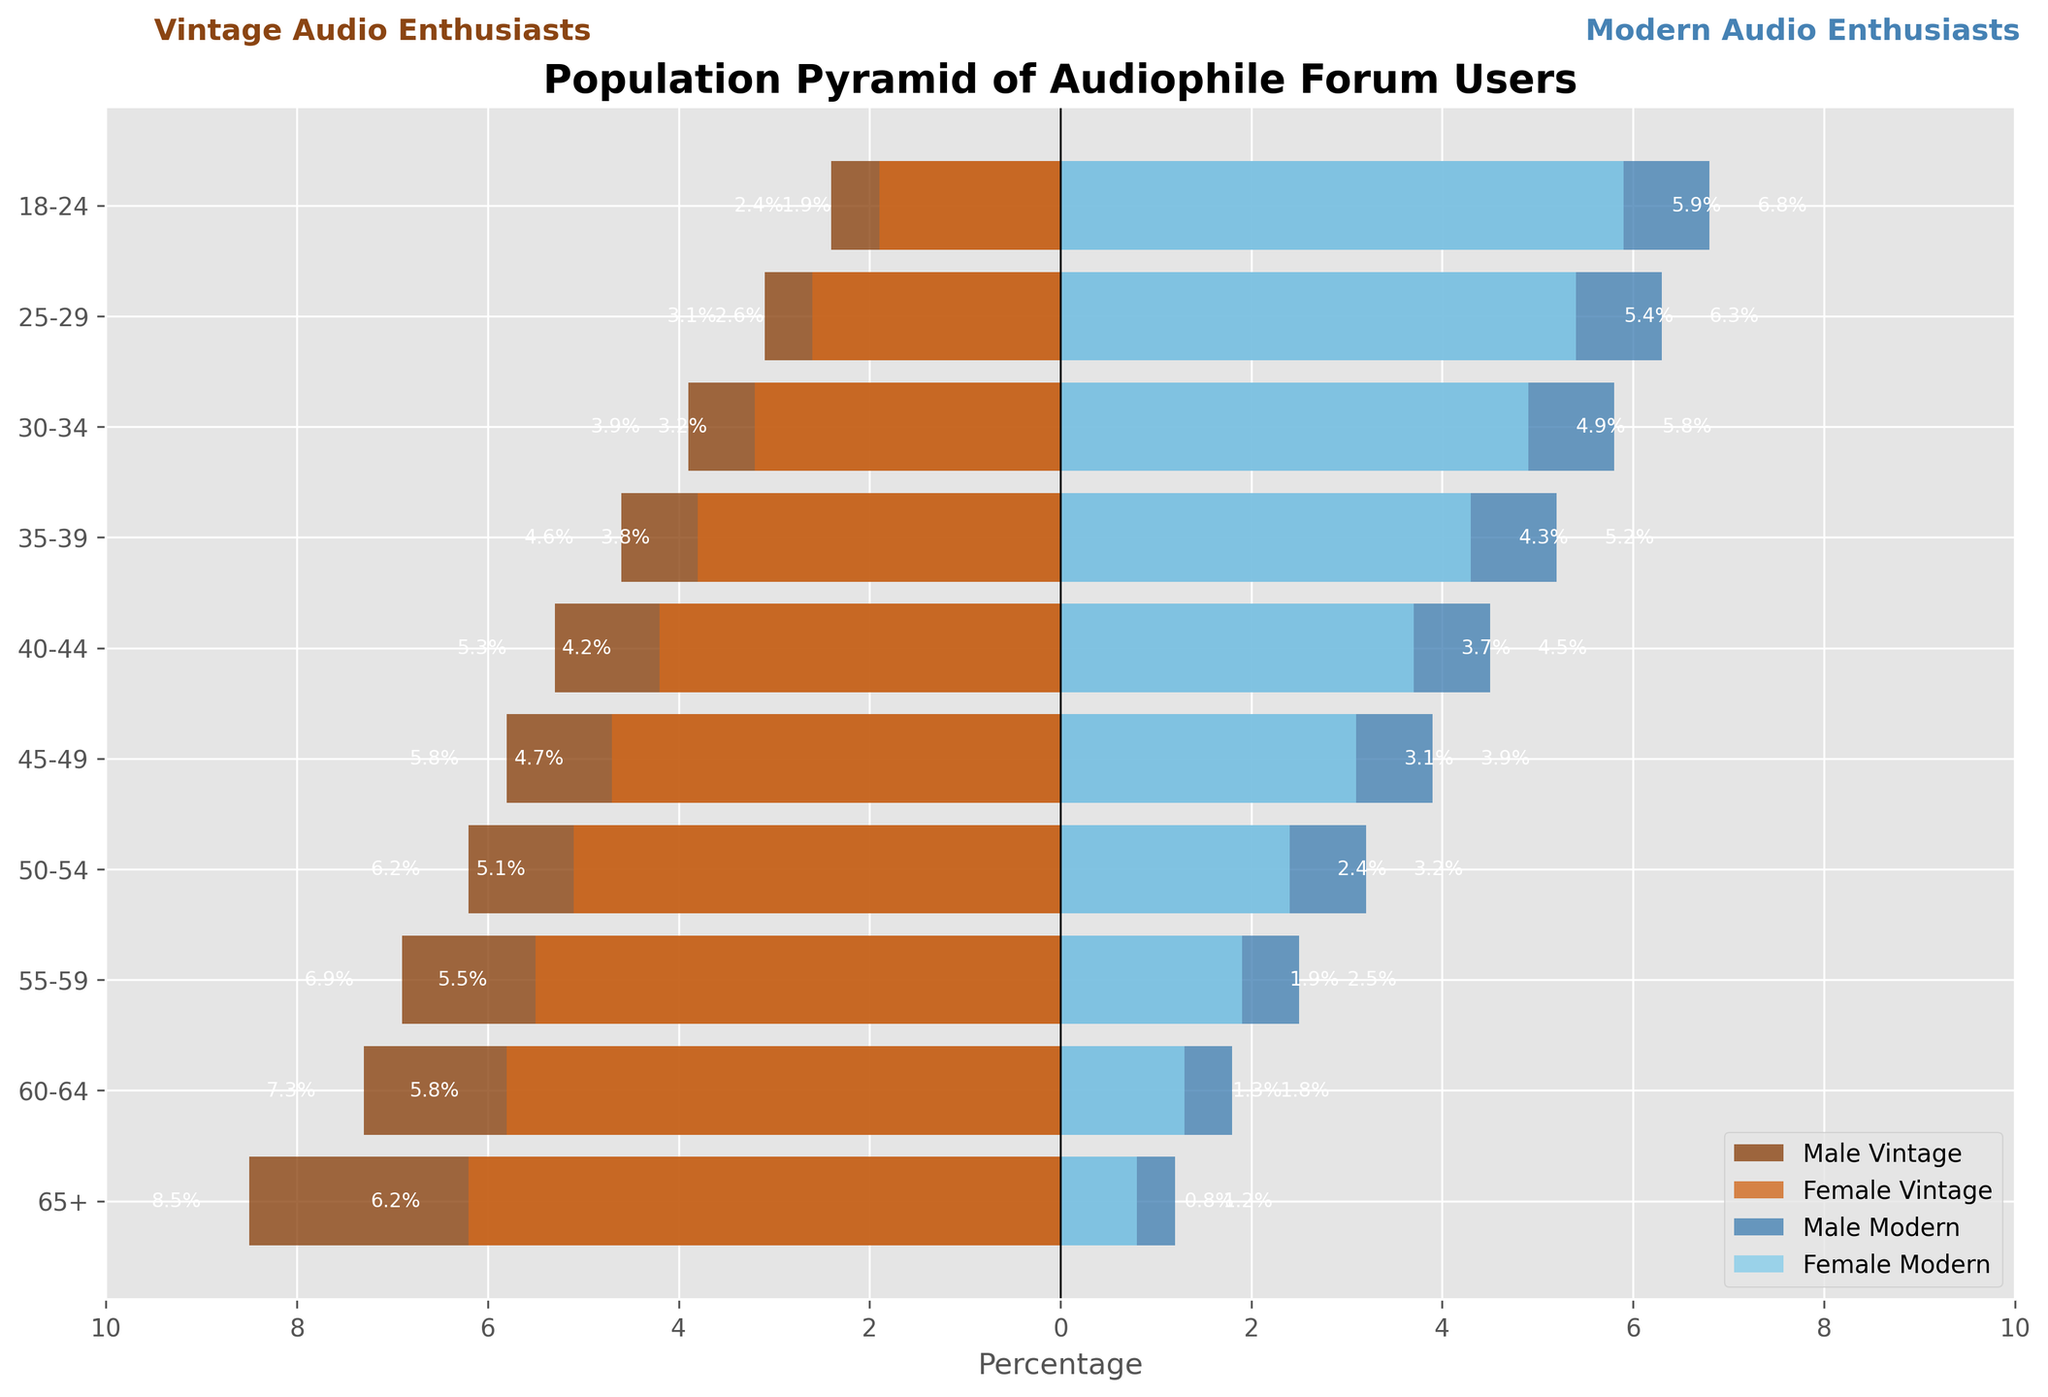What is the title of the figure? The title of the figure is written at the top and is 'Population Pyramid of Audiophile Forum Users'.
Answer: 'Population Pyramid of Audiophile Forum Users' Which age group has the highest percentage of modern audio enthusiasts? The highest bars in the modern audio enthusiasts category fall under the age group '18-24', showing both males and females with percentages 6.8% for males and 5.9% for females.
Answer: '18-24' What is the percentage difference between male vintage and male modern enthusiasts in the '55-59' age group? For the '55-59' age group, the percentage of male vintage enthusiasts is 6.9% and the percentage of male modern enthusiasts is 2.5%. The difference is 6.9% - 2.5% = 4.4%.
Answer: 4.4% Which gender has a higher percentage of modern audio enthusiasts in the '30-34' age group, and what is the difference? For the '30-34' age group, male modern enthusiasts have a percentage of 5.8% while female modern enthusiasts have a percentage of 4.9%. Males have a higher percentage, and the difference is 5.8% - 4.9% = 0.9%.
Answer: Males, 0.9% In which age group do female vintage enthusiasts have the least percentage representation, and what is that percentage? The lowest percentage for female vintage enthusiasts is in the '18-24' age group, showing a percentage of 1.9%.
Answer: '18-24', 1.9% How does the percentage of male vintage enthusiasts in the '65+' age group compare to the percentage of male modern enthusiasts in the same age group? In the '65+' age group, male vintage enthusiasts are at 8.5%, while male modern enthusiasts are at 1.2%. The percentage of male vintage enthusiasts is significantly higher.
Answer: Male vintage enthusiasts are higher, by 7.3% What is the combined percentage of vintage enthusiasts (both genders) in the '40-44' age group? The combined percentage of vintage enthusiasts in the '40-44' age group is the sum of 5.3% (male) and 4.2% (female), which equals 9.5%.
Answer: 9.5% Which age group shows a balanced gender distribution among modern audio enthusiasts, and what evidence supports this observation? The '45-49' age group shows a balanced distribution among modern audio enthusiasts, with males at 3.9% and females at 3.1%. The percentages are close, indicating balanced gender distribution.
Answer: '45-49', because the percentages for males and females are close, 3.9% and 3.1% What general trend can be observed from the comparison of modern and vintage enthusiasts across age groups? The general trend shows that younger age groups ('18-24' to '30-34') have more modern enthusiasts, while older age groups ('65+' to '40-44') have more vintage enthusiasts.
Answer: Younger ages prefer modern, older ages prefer vintage 